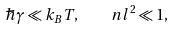Convert formula to latex. <formula><loc_0><loc_0><loc_500><loc_500>\hbar { \gamma } \ll k _ { B } T , \quad n l ^ { 2 } \ll 1 ,</formula> 